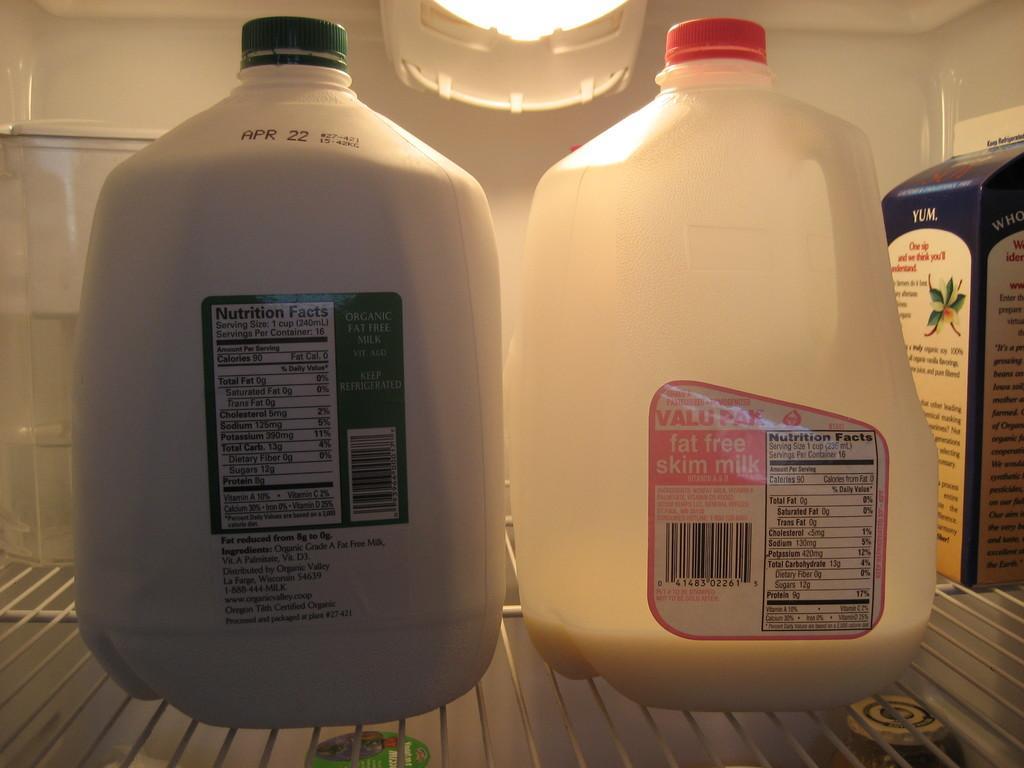Could you give a brief overview of what you see in this image? In this image I can see two bottles in white color and I can also see the cardboard box. Background I can see the light. 